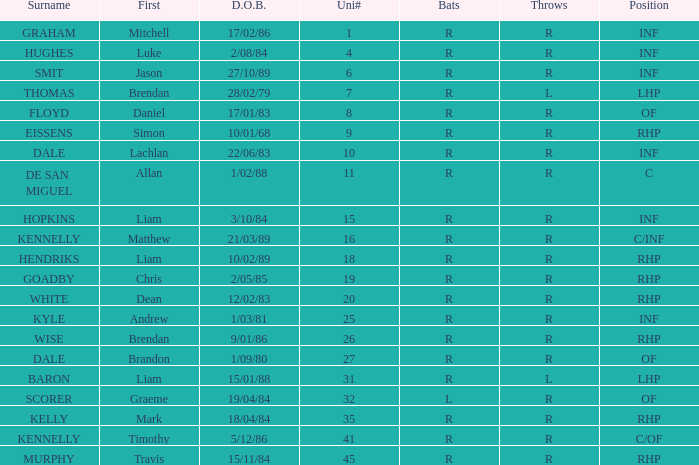Which batsman has a uni# of 31? R. 